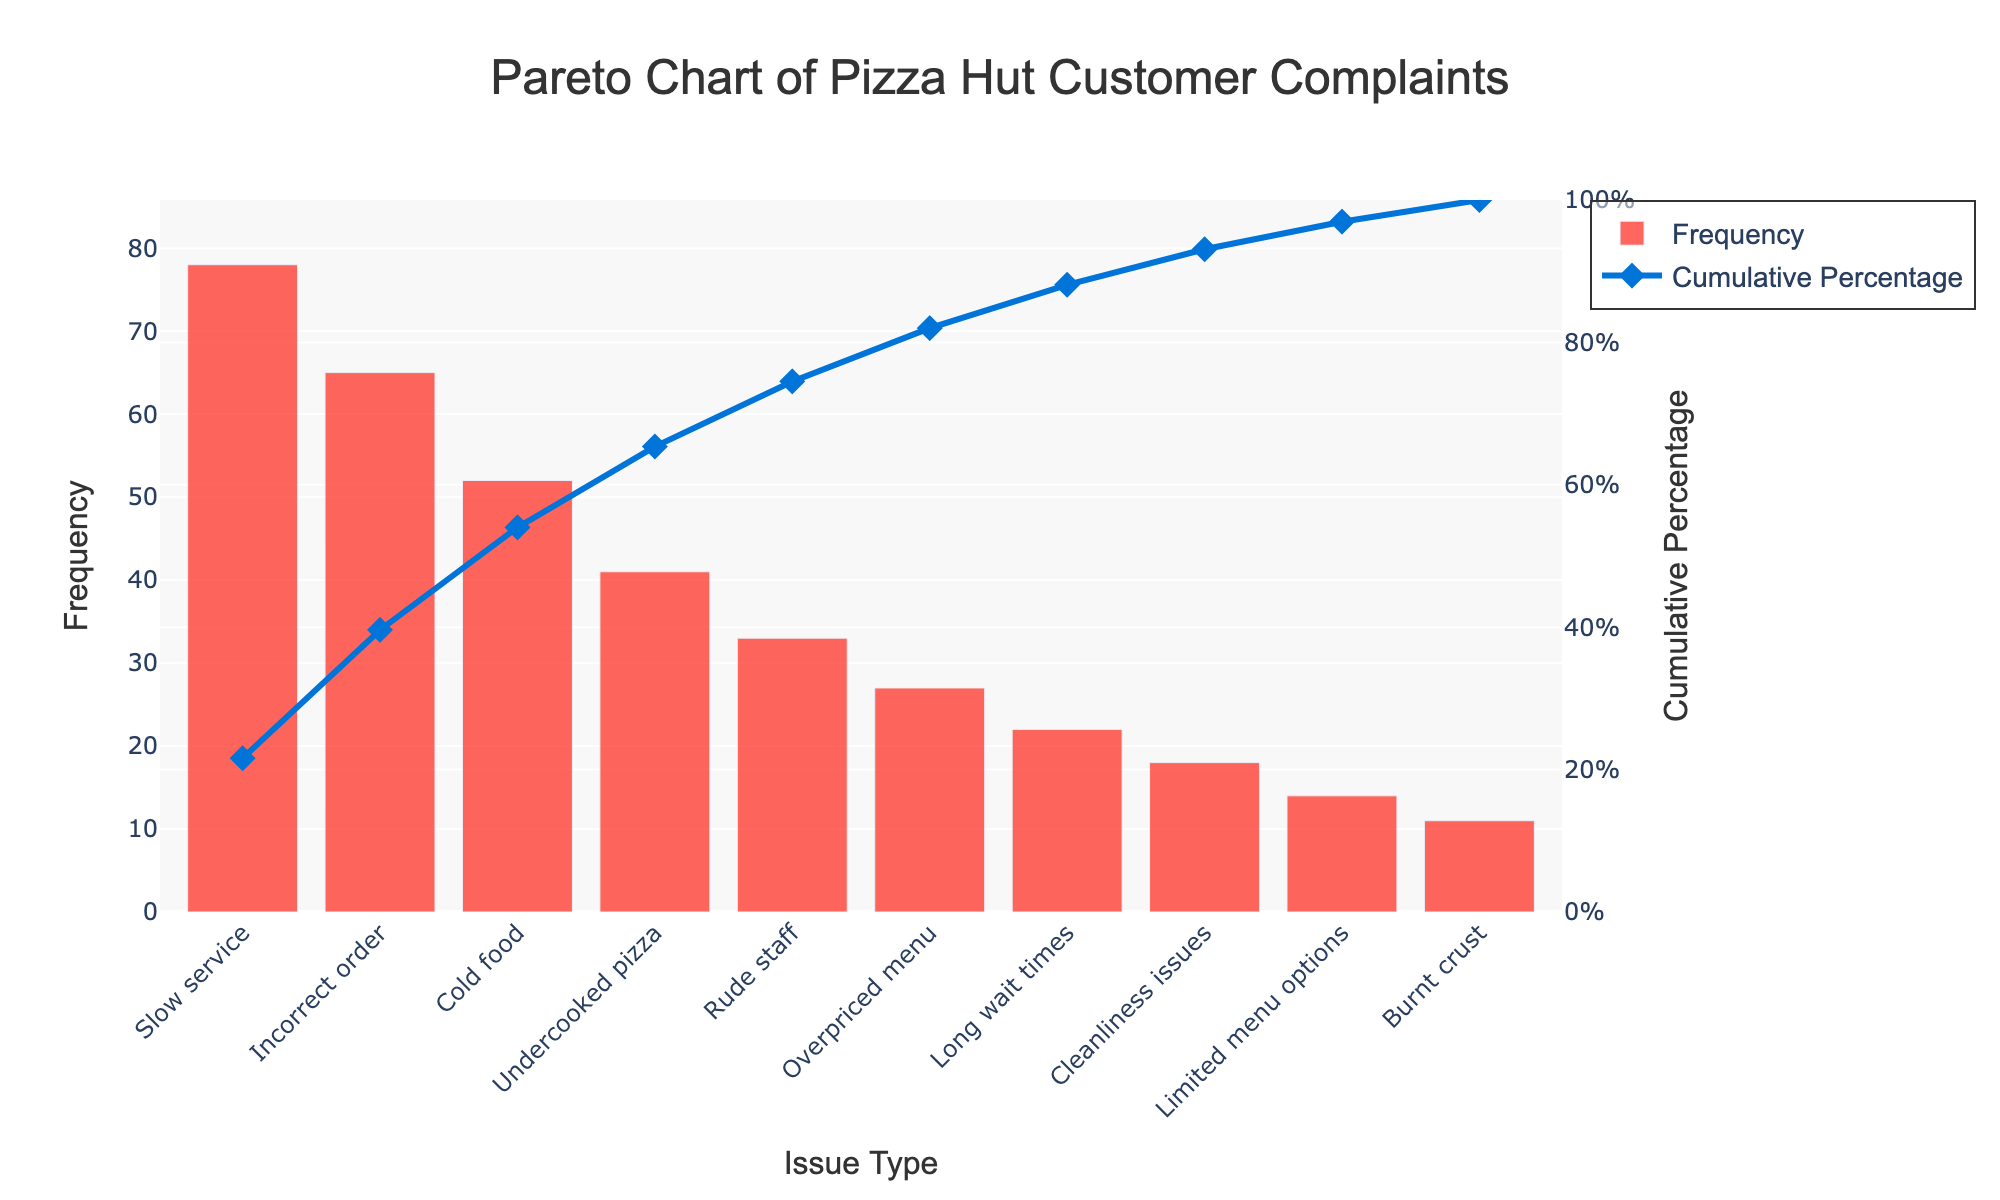What is the most frequent type of customer complaint? The most frequent type of customer complaint corresponds to the highest bar on the Pareto chart, which represents 'Slow service' with a frequency of 78.
Answer: Slow service Which two complaint types contribute to more than 50% of the total complaints? To find the two complaint types contributing to more than 50% of the total complaints, look at the cumulative percentage line. By checking the values, 'Slow service' and 'Incorrect order' together exceed 50% (43.3% + 35.1%).
Answer: Slow service and Incorrect order What percentage of complaints is attributed to 'Cold food'? Check the cumulative percentage related to 'Cold food' by identifying its corresponding point on the cumulative percentage line, which is approximately 77.0%. Then subtract the cumulative percentage of the previous complaint type, which is 'Incorrect order' at 43.3%. Therefore, 77.0% - 43.3% = 33.7%.
Answer: 33.7% How many complaint types are listed in the chart? Count the number of bars representing different complaint types. By observing the chart, there are 10 bars, each representing a unique complaint type.
Answer: 10 Which complaint has the least frequency? The complaint with the least frequency is represented by the shortest bar on the chart, which is 'Burnt crust' with a frequency of 11.
Answer: Burnt crust By fixing the top three complaint types, what portion of total complaints does Pizza Hut address? Calculate the cumulative percentage for the top three complaint types: 'Slow service,' 'Incorrect order,' and 'Cold food'. Their cumulative percentages are 43.3%, 43.3% + 35.1% = 78.4%, respectively. Thus, fixing these three complaints addresses 78.4% of total complaints.
Answer: 78.4% How does the complaint 'Undercooked pizza' compare in frequency to 'Cold food'? Compare the heights of the bars for 'Undercooked pizza' and 'Cold food'. 'Cold food' (52) has a higher frequency than 'Undercooked pizza' (41).
Answer: Cold food has a higher frequency What cumulative percentage is reached by addressing complaints up to 'Rude staff'? Add up the cumulative percentages of the issues up to 'Rude staff': 43.3% (Slow service), 78.4% (up to Cold food), and adding 51.8% (Undercooked pizza and Rude staff). The cumulative percentage is around 84.1%.
Answer: 84.1% What is the frequency difference between the most frequent and least frequent complaints? Find the frequency of the most frequent complaint 'Slow service' (78) and the least frequent complaint 'Burnt crust' (11). Subtract 11 from 78, resulting in a difference of 67.
Answer: 67 